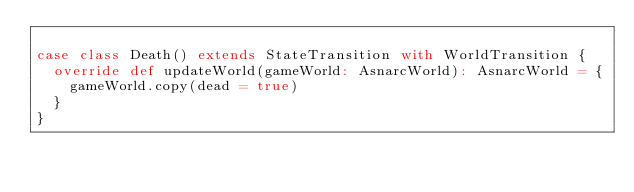<code> <loc_0><loc_0><loc_500><loc_500><_Scala_>
case class Death() extends StateTransition with WorldTransition {
  override def updateWorld(gameWorld: AsnarcWorld): AsnarcWorld = {
    gameWorld.copy(dead = true)
  }
}
</code> 